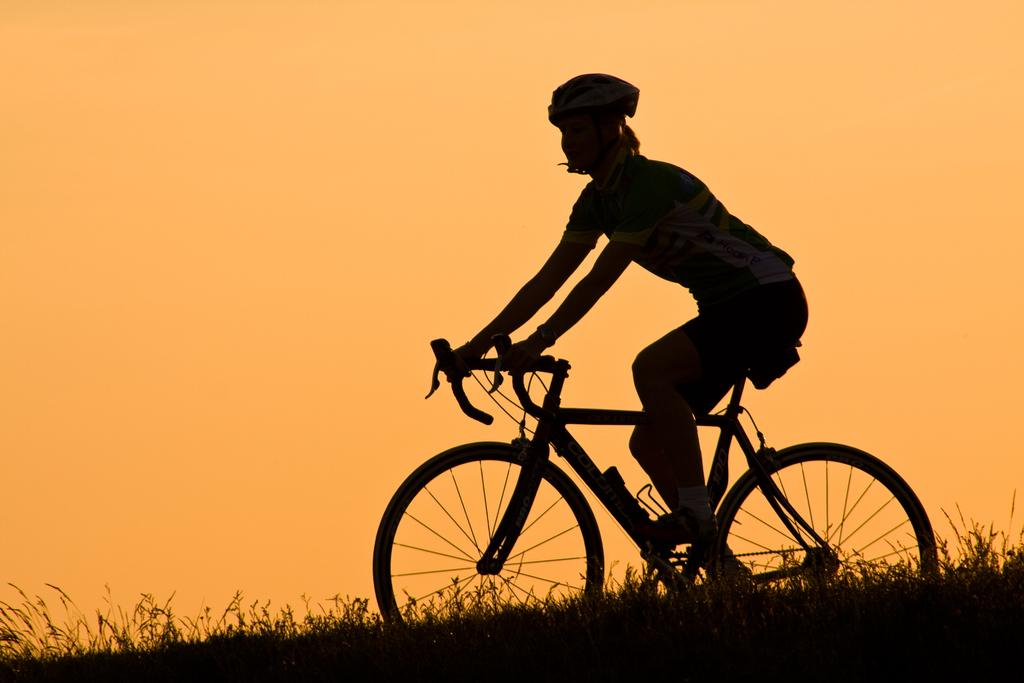Who is the main subject in the image? There is a woman in the image. What is the woman wearing on her head? The woman is wearing a helmet. What type of clothing is the woman wearing on her upper body? The woman is wearing a t-shirt.shirt. What type of clothing is the woman wearing on her lower body? The woman is wearing shorts. What type of footwear is the woman wearing? The woman is wearing shoes. What activity is the woman engaged in? The woman is riding a bicycle. What type of terrain is visible at the bottom of the image? There is grass visible at the bottom of the image. What is the color of the sky in the background of the image? The sky is orange in the background of the image. What direction is the woman riding her bicycle in the image? The image does not provide information about the direction the woman is riding her bicycle. What type of plane can be seen flying in the image? There is no plane visible in the image. 